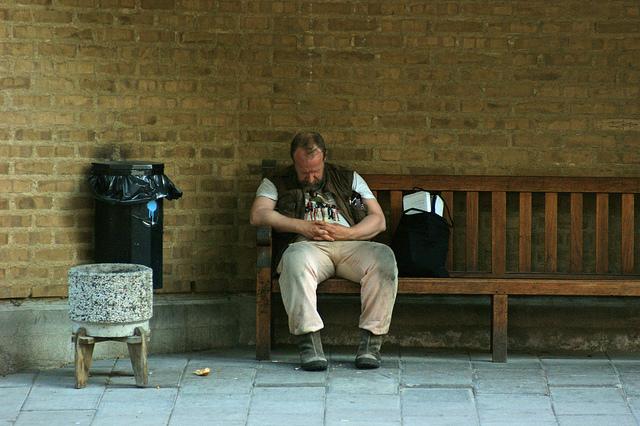Is this man wearing glasses?
Short answer required. No. What is left to the man?
Quick response, please. Trash can. Does the man appear dirty?
Give a very brief answer. Yes. What is the man doing on the bench?
Be succinct. Sleeping. 